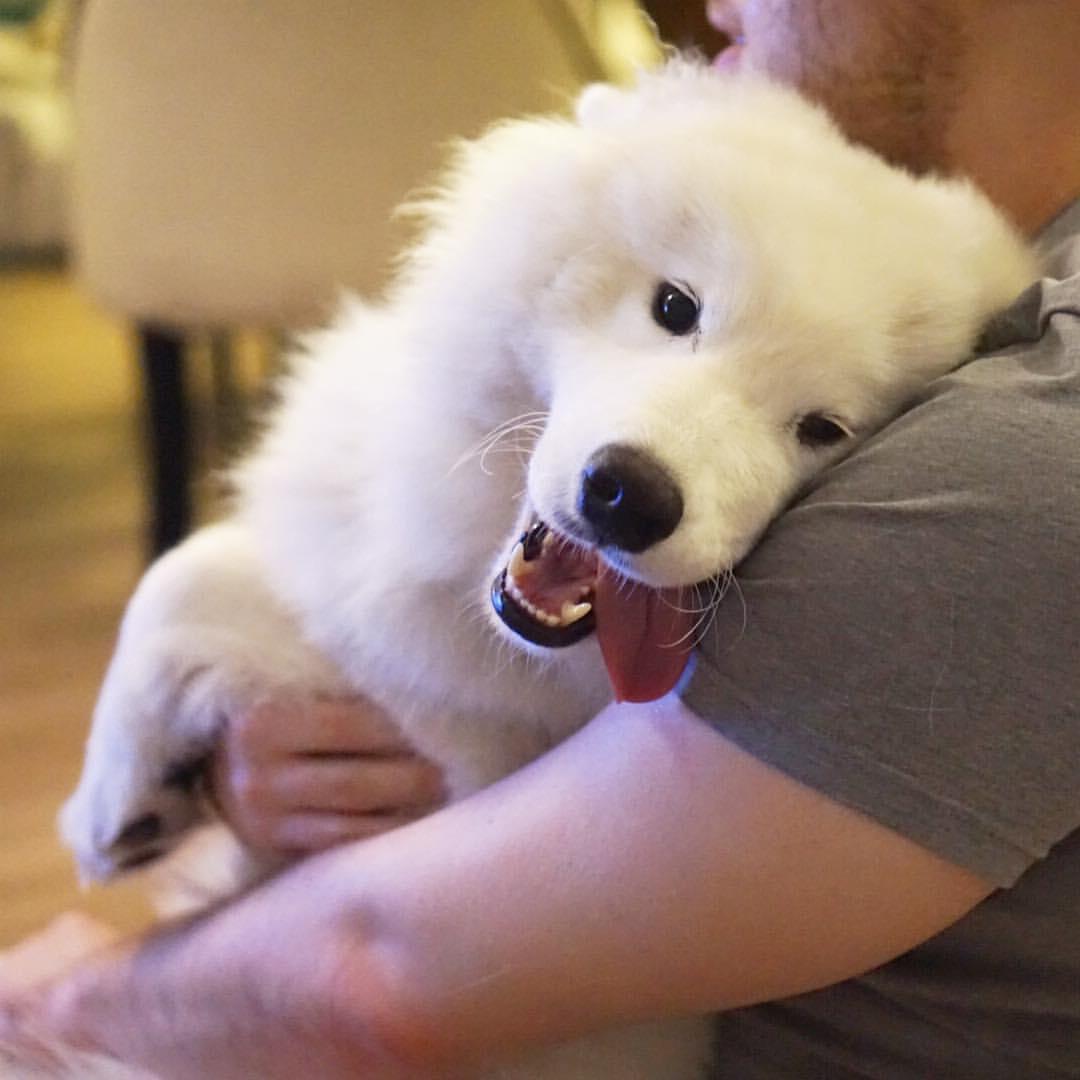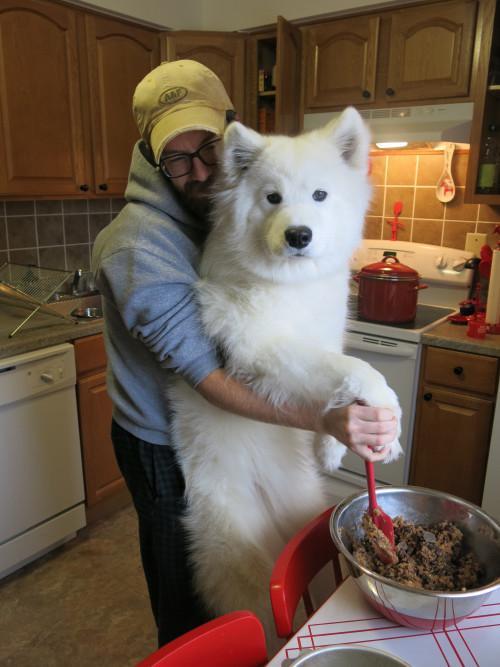The first image is the image on the left, the second image is the image on the right. Given the left and right images, does the statement "A person is posing with a white dog." hold true? Answer yes or no. Yes. The first image is the image on the left, the second image is the image on the right. For the images displayed, is the sentence "At least one image shows a person next to a big white dog." factually correct? Answer yes or no. Yes. 